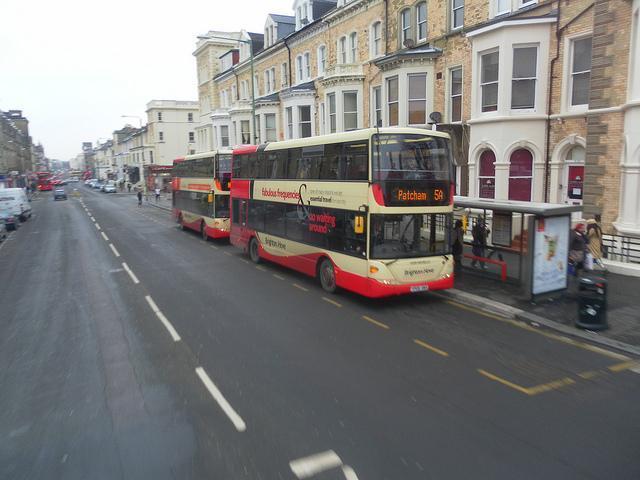How many buses are there?
Give a very brief answer. 2. How many people are at the bus stop?
Give a very brief answer. 2. How many buses can be seen?
Give a very brief answer. 2. 